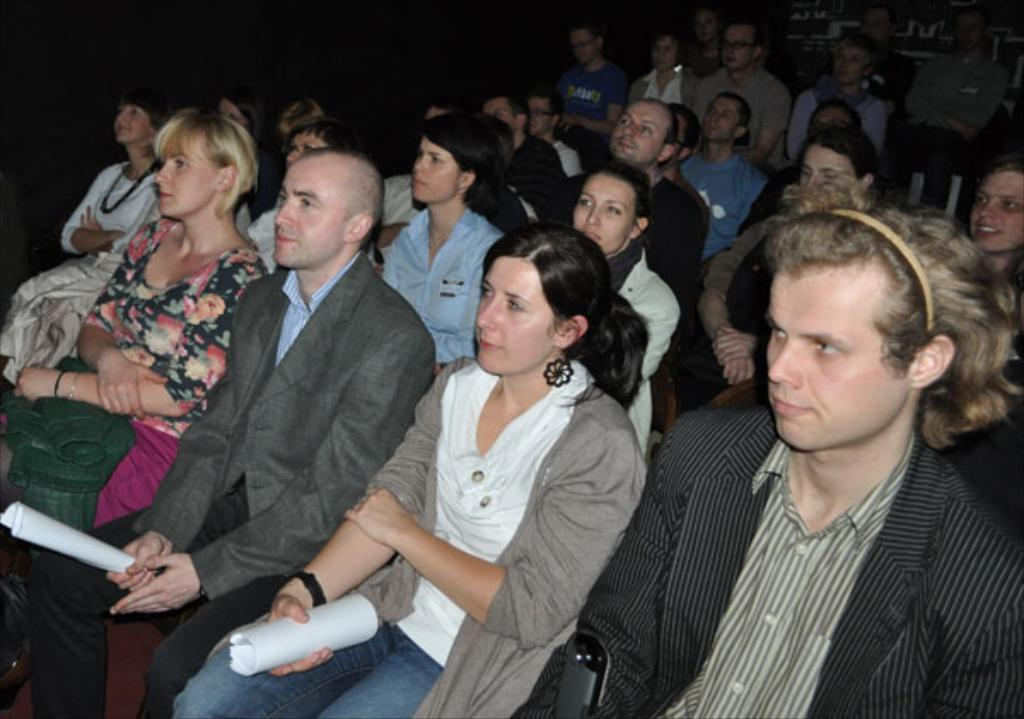What is happening in the image? There are many people sitting in the image. Can you describe any specific actions or objects being held by the people? Two people are holding papers in their hands. What is the color of the background in the image? The background of the image is black. What type of chin can be seen on the person with the haircut in the image? There is no person with a haircut in the image, and therefore no chin can be observed. What kind of stick is being used by the person with the beard in the image? There is no person with a beard or stick present in the image. 